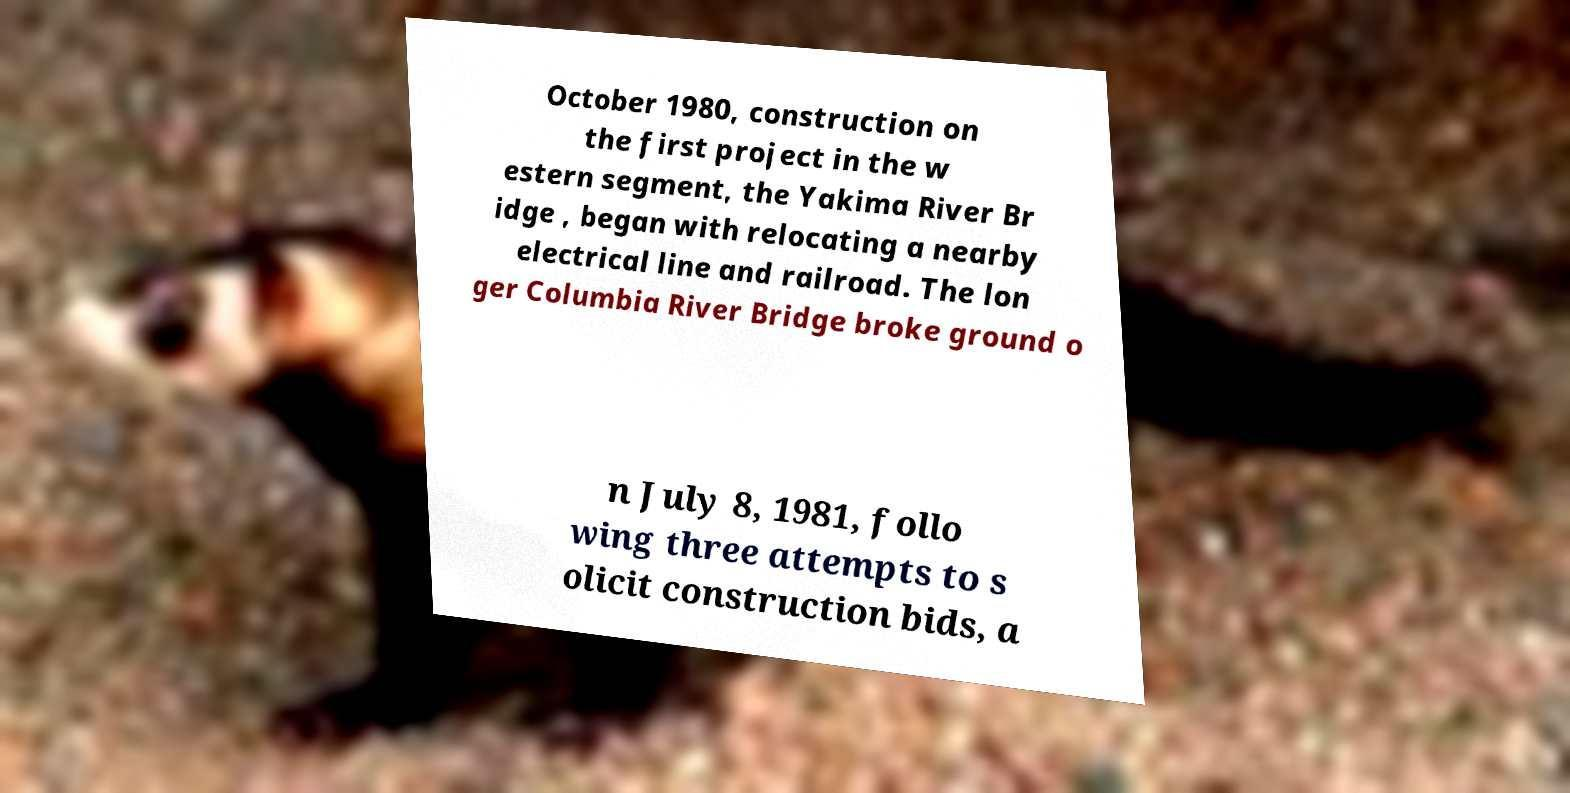There's text embedded in this image that I need extracted. Can you transcribe it verbatim? October 1980, construction on the first project in the w estern segment, the Yakima River Br idge , began with relocating a nearby electrical line and railroad. The lon ger Columbia River Bridge broke ground o n July 8, 1981, follo wing three attempts to s olicit construction bids, a 